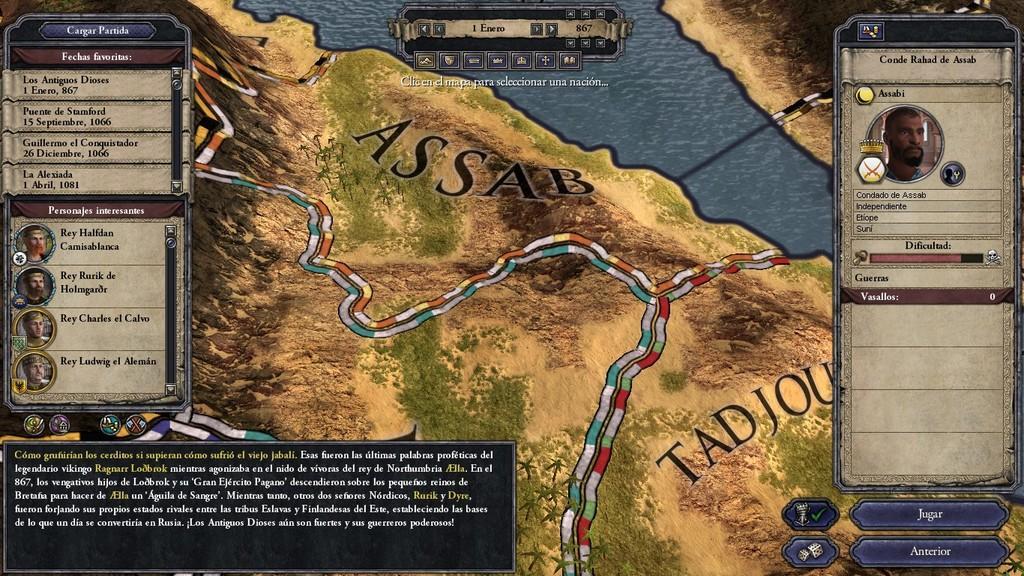Please provide a concise description of this image. In this image I can see the screenshot of the game and I can see few people faces and something is written on it and it is an colorful image. 